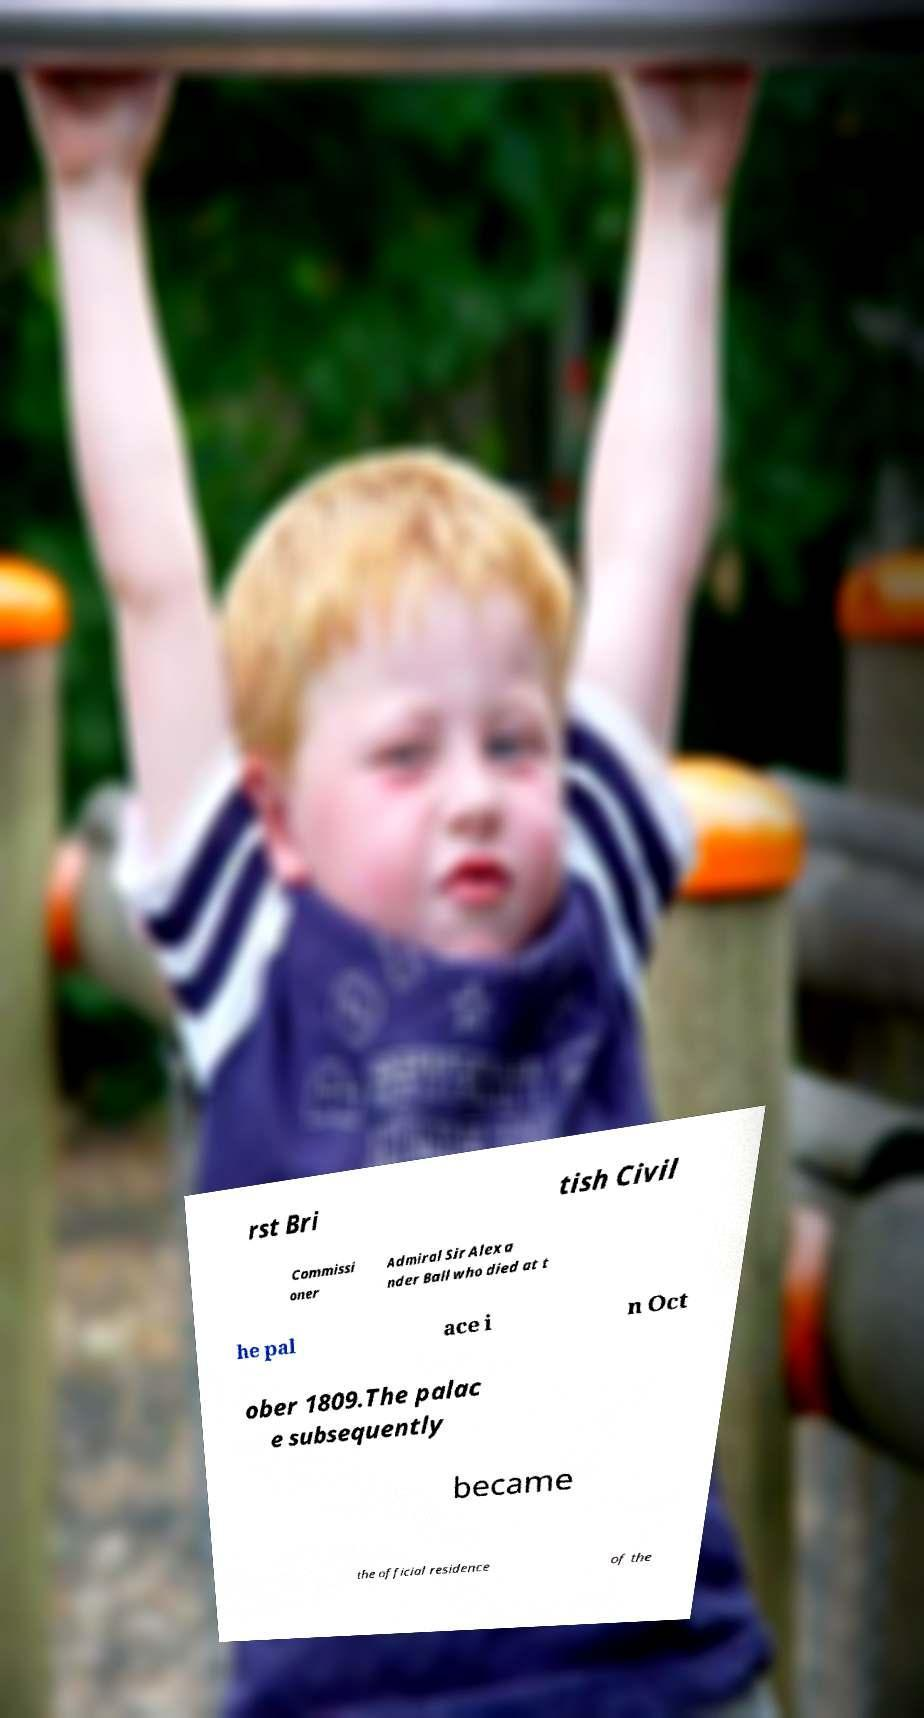What messages or text are displayed in this image? I need them in a readable, typed format. rst Bri tish Civil Commissi oner Admiral Sir Alexa nder Ball who died at t he pal ace i n Oct ober 1809.The palac e subsequently became the official residence of the 